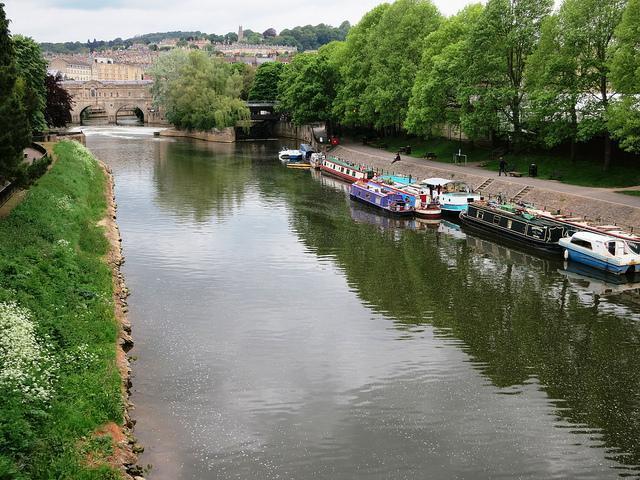How many boats can be seen?
Give a very brief answer. 2. 